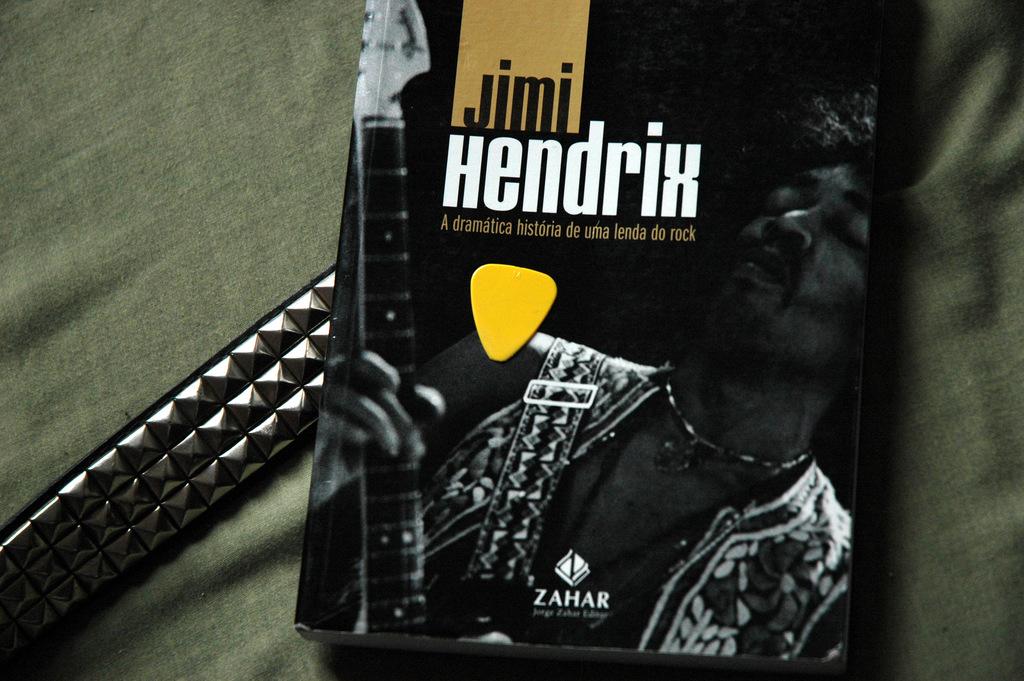Who is the artist?
Offer a terse response. Jimi hendrix. What brand is advertised at the bottom of the picture?
Keep it short and to the point. Zahar. 